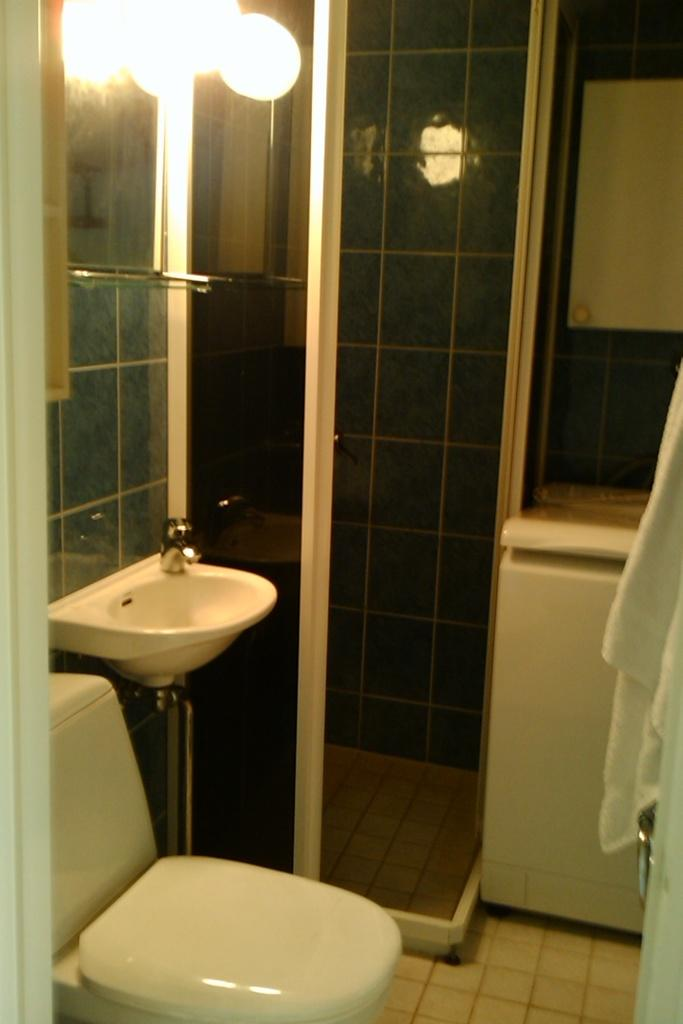What is the main fixture in the image? There is a toilet seat in the image. What is another fixture that can be seen in the image? There is a wash basin with a tap in the image. What can be used to illuminate the room in the image? There are lights visible in the image. What is located on the right side of the image? There is a towel on the right side of the image. What else can be found on the floor in the image? There are other objects on the floor in the image. How many fish are swimming in the toilet bowl in the image? There are no fish present in the image, as it features a toilet seat and a wash basin. 